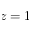Convert formula to latex. <formula><loc_0><loc_0><loc_500><loc_500>z = 1</formula> 